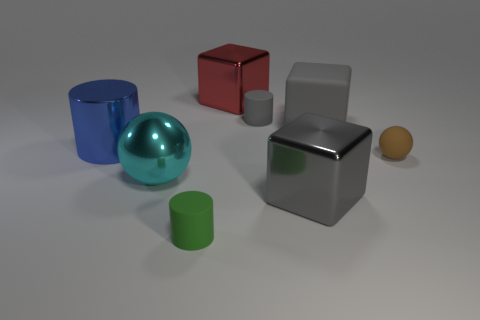There is a metal thing that is the same color as the large matte thing; what size is it?
Your answer should be compact. Large. How many big purple spheres are there?
Offer a very short reply. 0. How many blocks are either big purple objects or red objects?
Offer a terse response. 1. How many large gray blocks are in front of the ball that is right of the metallic object in front of the big cyan ball?
Provide a short and direct response. 1. The matte cube that is the same size as the blue thing is what color?
Provide a succinct answer. Gray. How many other objects are the same color as the big metallic ball?
Provide a succinct answer. 0. Is the number of tiny cylinders behind the large shiny cylinder greater than the number of big green shiny spheres?
Ensure brevity in your answer.  Yes. Are the tiny brown sphere and the big sphere made of the same material?
Keep it short and to the point. No. What number of things are either big things in front of the red object or small red metallic cylinders?
Provide a short and direct response. 4. How many other things are there of the same size as the red shiny cube?
Offer a very short reply. 4. 